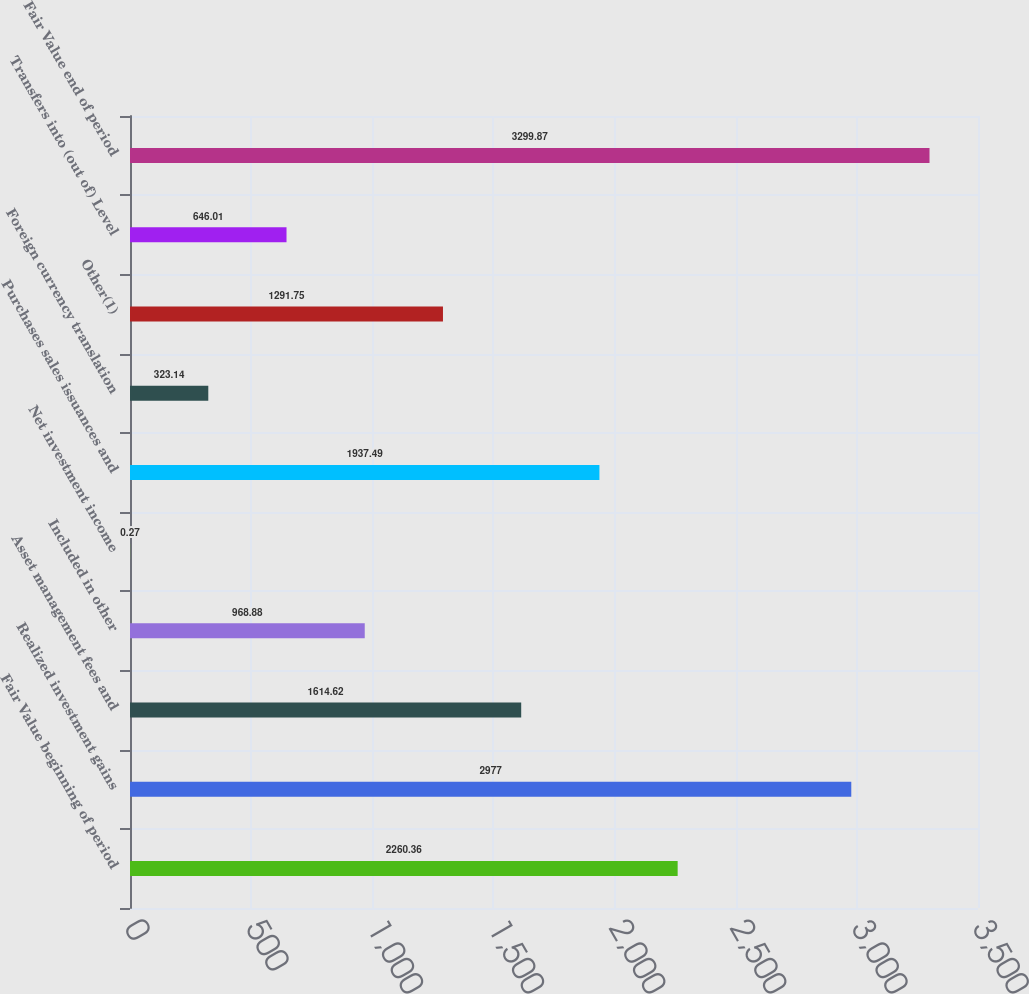<chart> <loc_0><loc_0><loc_500><loc_500><bar_chart><fcel>Fair Value beginning of period<fcel>Realized investment gains<fcel>Asset management fees and<fcel>Included in other<fcel>Net investment income<fcel>Purchases sales issuances and<fcel>Foreign currency translation<fcel>Other(1)<fcel>Transfers into (out of) Level<fcel>Fair Value end of period<nl><fcel>2260.36<fcel>2977<fcel>1614.62<fcel>968.88<fcel>0.27<fcel>1937.49<fcel>323.14<fcel>1291.75<fcel>646.01<fcel>3299.87<nl></chart> 